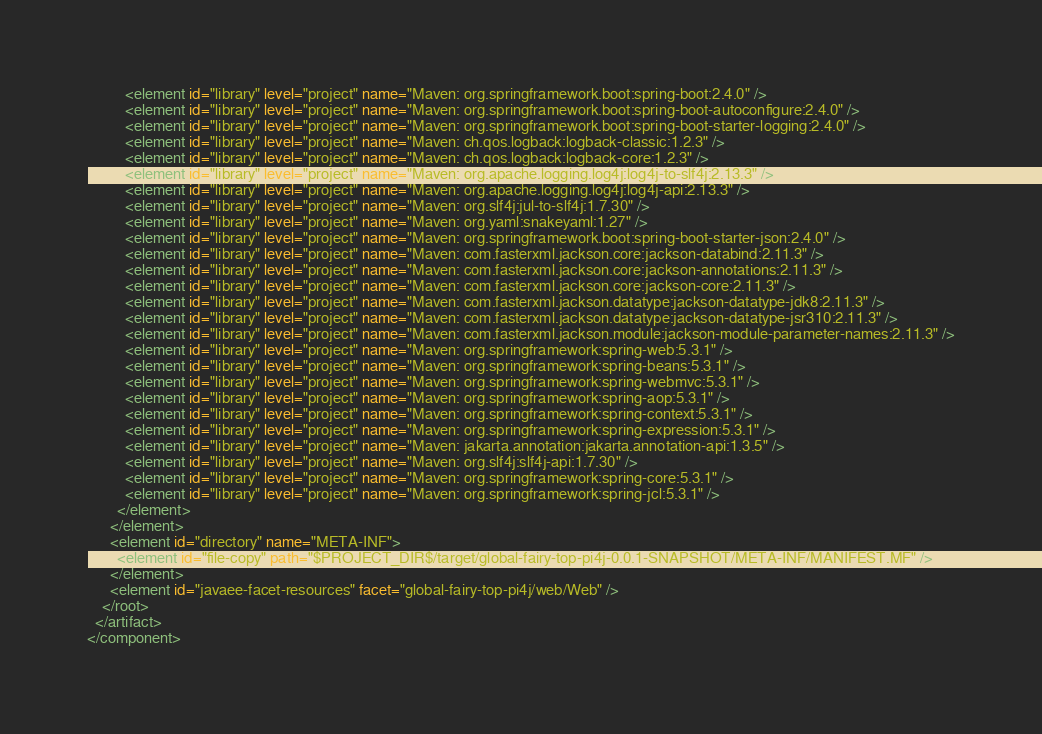<code> <loc_0><loc_0><loc_500><loc_500><_XML_>          <element id="library" level="project" name="Maven: org.springframework.boot:spring-boot:2.4.0" />
          <element id="library" level="project" name="Maven: org.springframework.boot:spring-boot-autoconfigure:2.4.0" />
          <element id="library" level="project" name="Maven: org.springframework.boot:spring-boot-starter-logging:2.4.0" />
          <element id="library" level="project" name="Maven: ch.qos.logback:logback-classic:1.2.3" />
          <element id="library" level="project" name="Maven: ch.qos.logback:logback-core:1.2.3" />
          <element id="library" level="project" name="Maven: org.apache.logging.log4j:log4j-to-slf4j:2.13.3" />
          <element id="library" level="project" name="Maven: org.apache.logging.log4j:log4j-api:2.13.3" />
          <element id="library" level="project" name="Maven: org.slf4j:jul-to-slf4j:1.7.30" />
          <element id="library" level="project" name="Maven: org.yaml:snakeyaml:1.27" />
          <element id="library" level="project" name="Maven: org.springframework.boot:spring-boot-starter-json:2.4.0" />
          <element id="library" level="project" name="Maven: com.fasterxml.jackson.core:jackson-databind:2.11.3" />
          <element id="library" level="project" name="Maven: com.fasterxml.jackson.core:jackson-annotations:2.11.3" />
          <element id="library" level="project" name="Maven: com.fasterxml.jackson.core:jackson-core:2.11.3" />
          <element id="library" level="project" name="Maven: com.fasterxml.jackson.datatype:jackson-datatype-jdk8:2.11.3" />
          <element id="library" level="project" name="Maven: com.fasterxml.jackson.datatype:jackson-datatype-jsr310:2.11.3" />
          <element id="library" level="project" name="Maven: com.fasterxml.jackson.module:jackson-module-parameter-names:2.11.3" />
          <element id="library" level="project" name="Maven: org.springframework:spring-web:5.3.1" />
          <element id="library" level="project" name="Maven: org.springframework:spring-beans:5.3.1" />
          <element id="library" level="project" name="Maven: org.springframework:spring-webmvc:5.3.1" />
          <element id="library" level="project" name="Maven: org.springframework:spring-aop:5.3.1" />
          <element id="library" level="project" name="Maven: org.springframework:spring-context:5.3.1" />
          <element id="library" level="project" name="Maven: org.springframework:spring-expression:5.3.1" />
          <element id="library" level="project" name="Maven: jakarta.annotation:jakarta.annotation-api:1.3.5" />
          <element id="library" level="project" name="Maven: org.slf4j:slf4j-api:1.7.30" />
          <element id="library" level="project" name="Maven: org.springframework:spring-core:5.3.1" />
          <element id="library" level="project" name="Maven: org.springframework:spring-jcl:5.3.1" />
        </element>
      </element>
      <element id="directory" name="META-INF">
        <element id="file-copy" path="$PROJECT_DIR$/target/global-fairy-top-pi4j-0.0.1-SNAPSHOT/META-INF/MANIFEST.MF" />
      </element>
      <element id="javaee-facet-resources" facet="global-fairy-top-pi4j/web/Web" />
    </root>
  </artifact>
</component></code> 